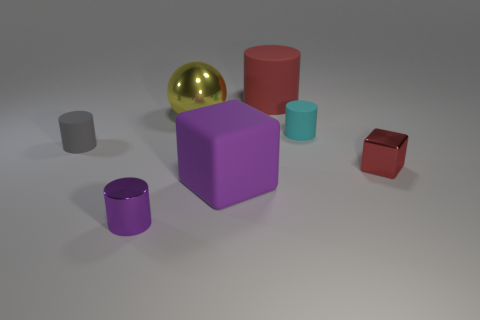What is the color of the largest block in the image? The largest block in the image is purple. 